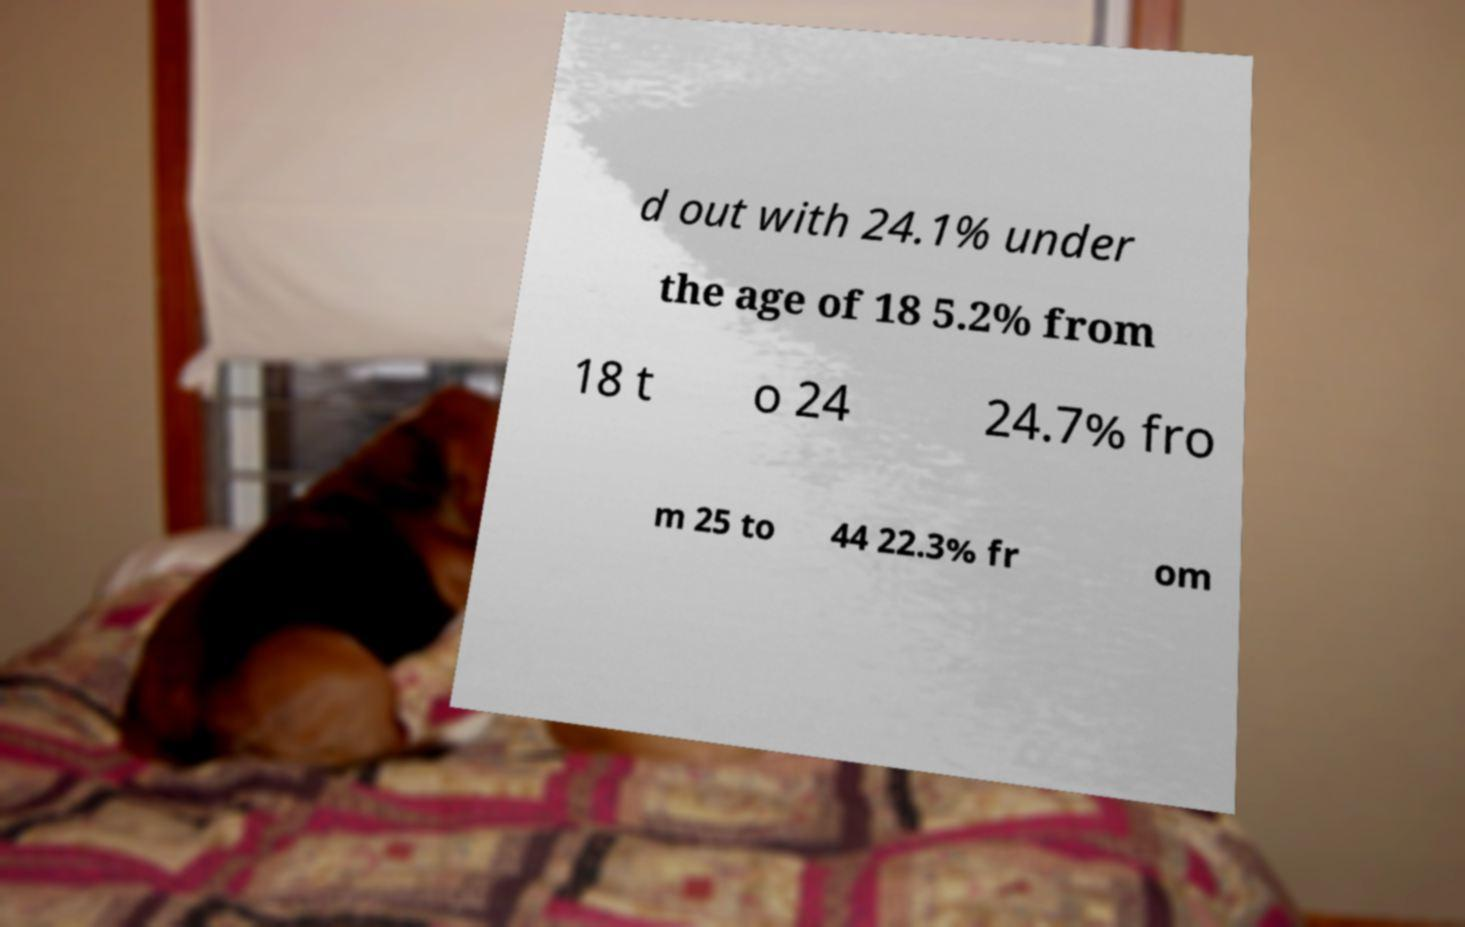Can you accurately transcribe the text from the provided image for me? d out with 24.1% under the age of 18 5.2% from 18 t o 24 24.7% fro m 25 to 44 22.3% fr om 